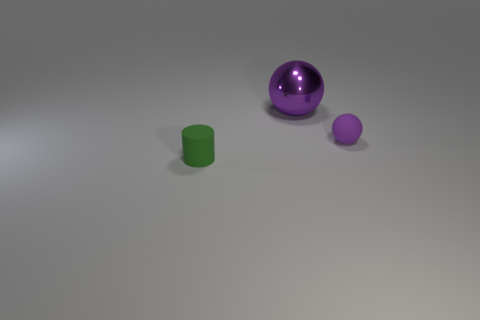Add 3 metallic spheres. How many objects exist? 6 Subtract all spheres. How many objects are left? 1 Subtract all big objects. Subtract all big gray shiny spheres. How many objects are left? 2 Add 1 tiny things. How many tiny things are left? 3 Add 2 small purple shiny objects. How many small purple shiny objects exist? 2 Subtract 0 brown blocks. How many objects are left? 3 